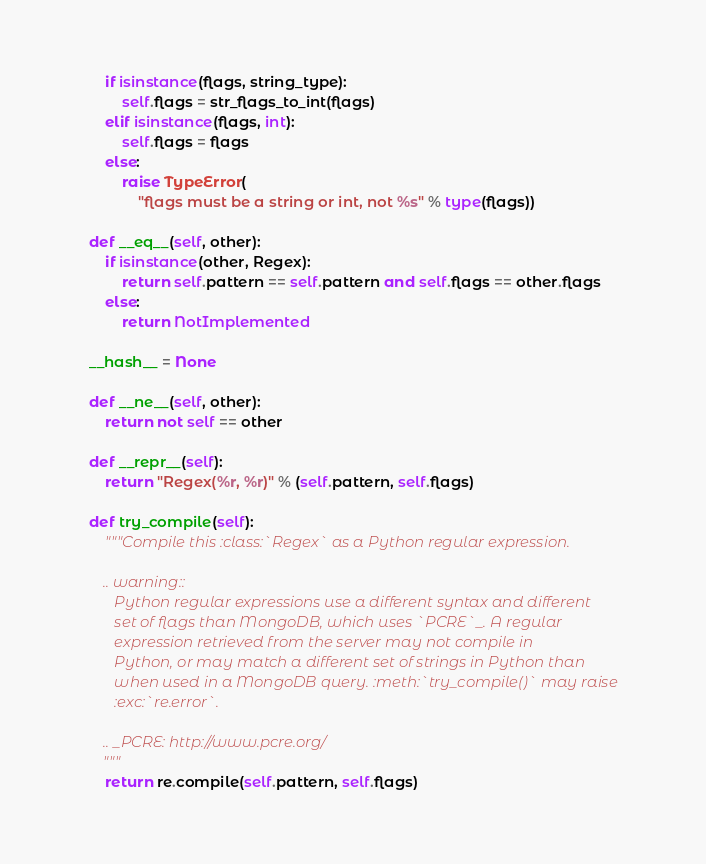<code> <loc_0><loc_0><loc_500><loc_500><_Python_>        if isinstance(flags, string_type):
            self.flags = str_flags_to_int(flags)
        elif isinstance(flags, int):
            self.flags = flags
        else:
            raise TypeError(
                "flags must be a string or int, not %s" % type(flags))

    def __eq__(self, other):
        if isinstance(other, Regex):
            return self.pattern == self.pattern and self.flags == other.flags
        else:
            return NotImplemented

    __hash__ = None

    def __ne__(self, other):
        return not self == other

    def __repr__(self):
        return "Regex(%r, %r)" % (self.pattern, self.flags)

    def try_compile(self):
        """Compile this :class:`Regex` as a Python regular expression.

        .. warning::
           Python regular expressions use a different syntax and different
           set of flags than MongoDB, which uses `PCRE`_. A regular
           expression retrieved from the server may not compile in
           Python, or may match a different set of strings in Python than
           when used in a MongoDB query. :meth:`try_compile()` may raise
           :exc:`re.error`.

        .. _PCRE: http://www.pcre.org/
        """
        return re.compile(self.pattern, self.flags)
</code> 